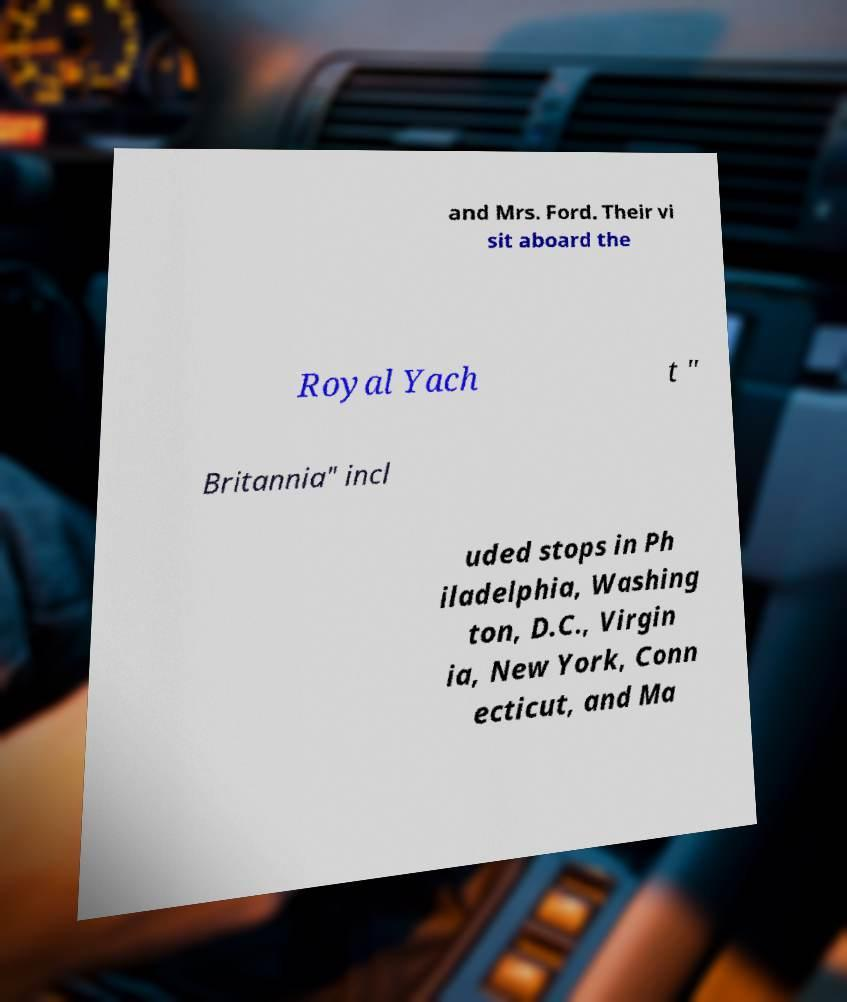Could you assist in decoding the text presented in this image and type it out clearly? and Mrs. Ford. Their vi sit aboard the Royal Yach t " Britannia" incl uded stops in Ph iladelphia, Washing ton, D.C., Virgin ia, New York, Conn ecticut, and Ma 